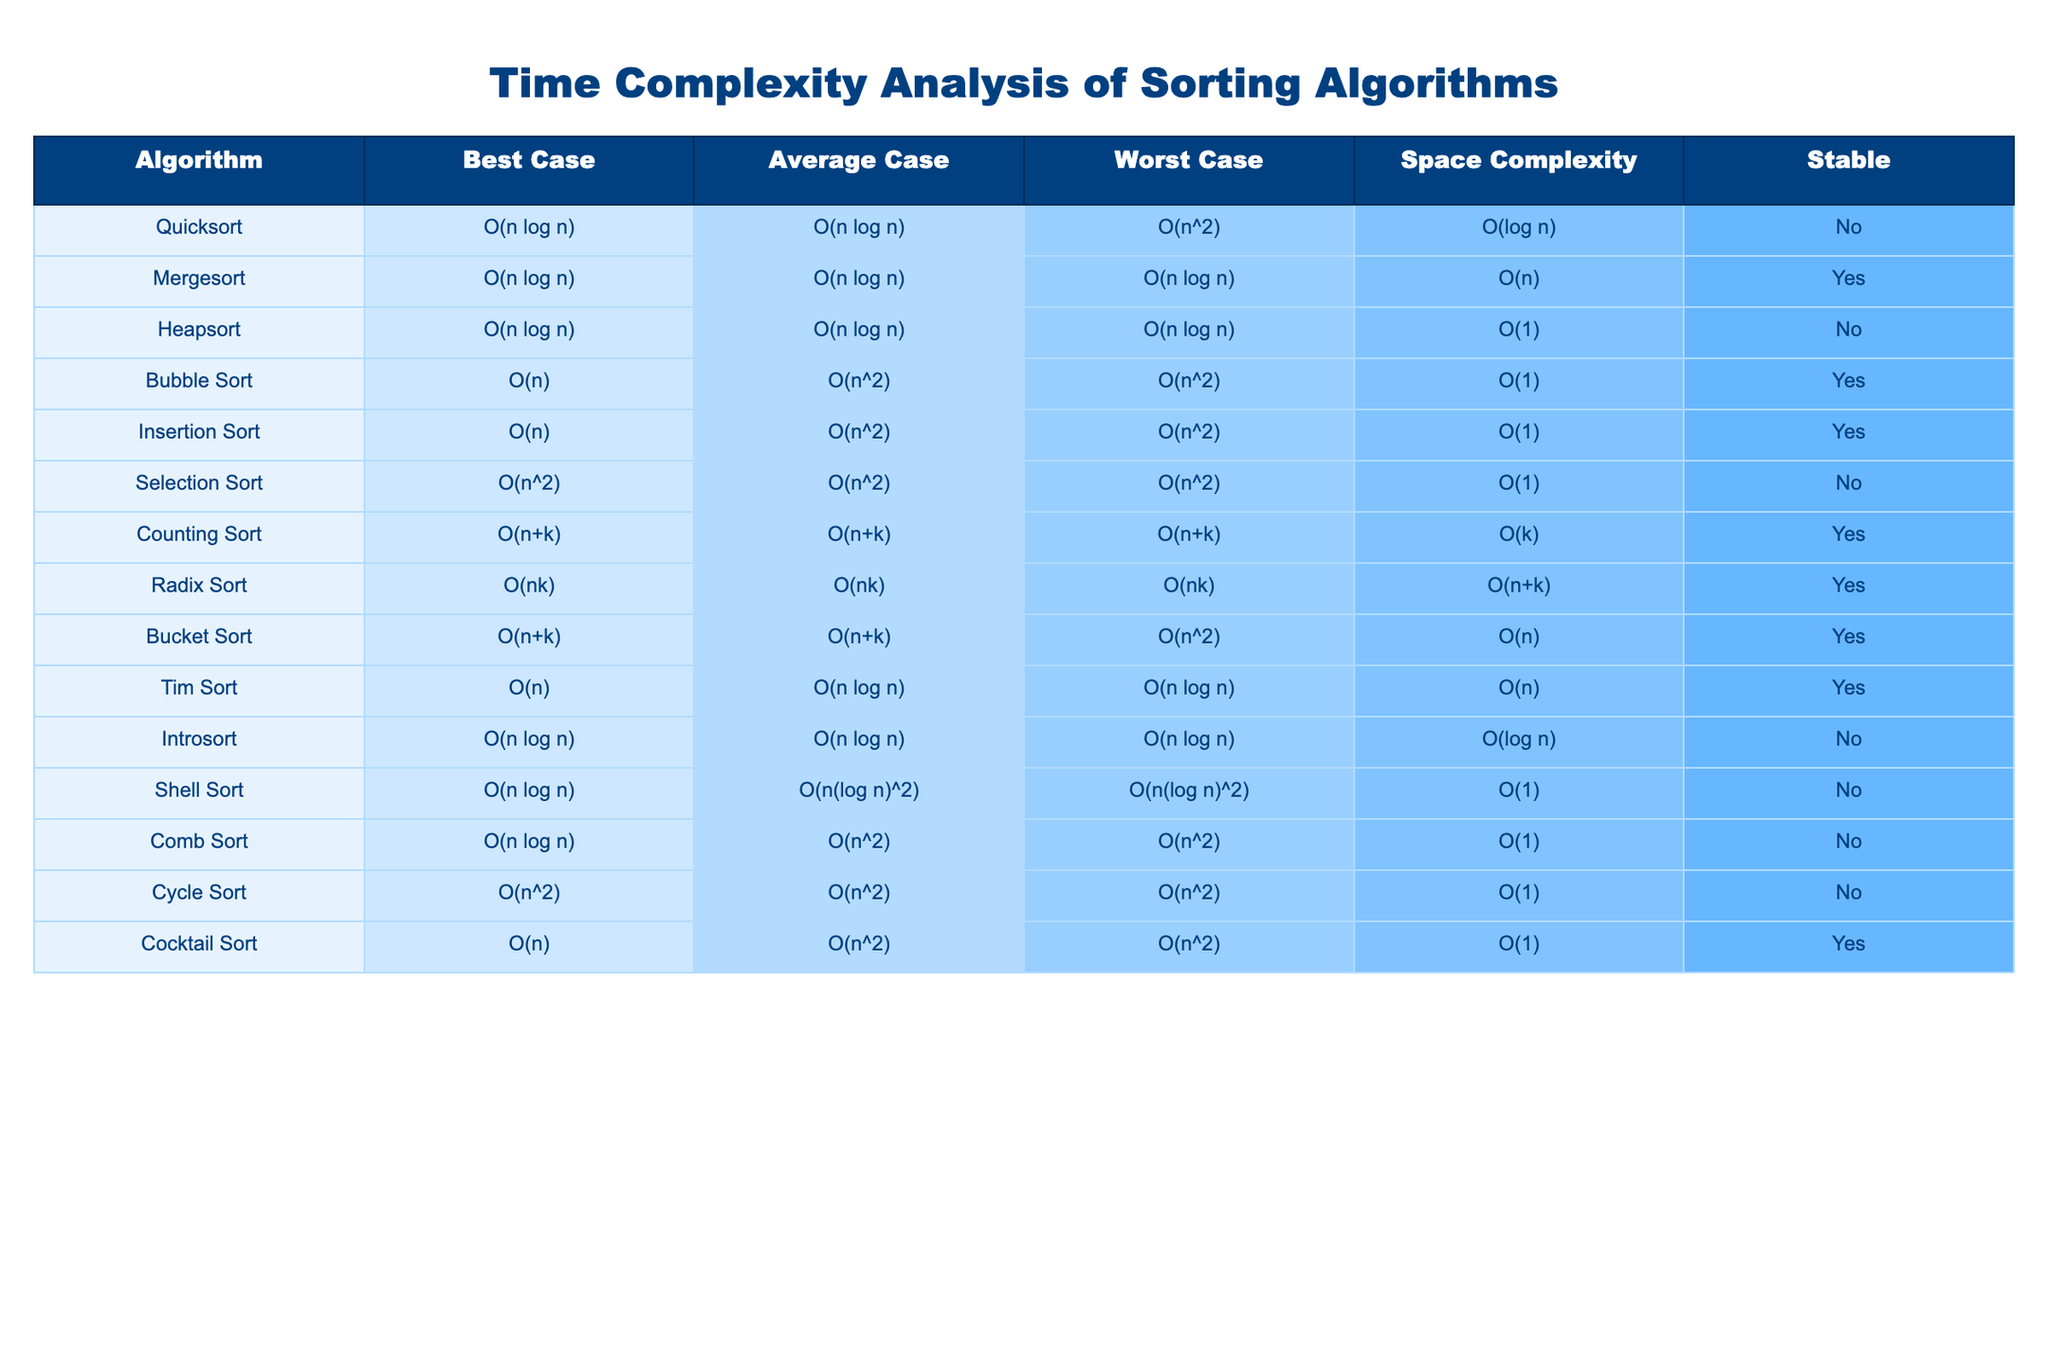What is the worst-case time complexity of Quicksort? Quicksort has a worst-case time complexity of O(n^2), which is clearly stated in the table under the "Worst Case" column for the Quicksort algorithm.
Answer: O(n^2) Which sorting algorithm has the best average case time complexity? By reviewing the "Average Case" column, Mergesort, Quicksort, and Heapsort all have an average case of O(n log n), which is the best among the listed algorithms.
Answer: O(n log n) Is Mergesort a stable sorting algorithm? Looking at the "Stable" column for Mergesort, it is indicated as "Yes," confirming that Mergesort is indeed a stable sorting algorithm.
Answer: Yes What is the space complexity of Counting Sort? In the "Space Complexity" column for Counting Sort, the complexity is listed as O(k), meaning that this is the amount of extra space needed for the algorithm during execution.
Answer: O(k) Which sorting algorithm has the worst-case time complexity of O(n^2)? The algorithms listed with a worst-case time complexity of O(n^2) include Bubble Sort, Insertion Sort, Selection Sort, Cycle Sort, and Cocktail Sort. This can be found by scanning the "Worst Case" column for the specified complexity.
Answer: Bubble Sort, Insertion Sort, Selection Sort, Cycle Sort, Cocktail Sort What is the difference between the best and worst-case time complexity of Selection Sort? The best-case time complexity for Selection Sort is O(n^2) and the worst-case is also O(n^2). Therefore, the difference is O(n^2) - O(n^2), which equals 0.
Answer: 0 How many sorting algorithms listed are stable? By checking the "Stable" column, Counting Sort, Mergesort, Tim Sort, Bubble Sort, Insertion Sort, Bucket Sort, and Cocktail Sort are marked as "Yes," totaling 7 stable algorithms.
Answer: 7 If we average the time complexities of Bubble Sort and Insertion Sort in the worst case, what do we get? Bubble Sort has a worst-case complexity of O(n^2) and Insertion Sort also has O(n^2). Averaging these gives O(n^2) because both are the same.
Answer: O(n^2) What is the space complexity of the fastest algorithm by average case? The algorithms Quicksort, Mergesort, and Heapsort are tied for the best average case complexity of O(n log n). Among these, Mergesort has a space complexity of O(n), which is the lowest among them. Thus, the answer is O(n).
Answer: O(n) Which algorithm has the best best-case time complexity and what is that complexity? The best-case time complexity of Bubble Sort is O(n), which is the best compared to others. This can be verified in the "Best Case" column.
Answer: O(n) 